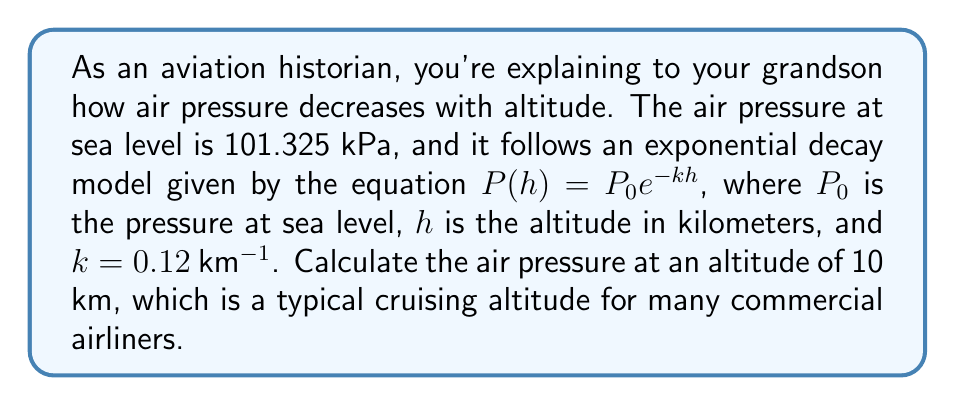Teach me how to tackle this problem. Let's approach this step-by-step:

1) We're given the exponential decay model:
   $P(h) = P_0 e^{-kh}$

2) We know the following values:
   $P_0 = 101.325$ kPa (pressure at sea level)
   $k = 0.12$ km^(-1)
   $h = 10$ km

3) Let's substitute these values into our equation:
   $P(10) = 101.325 \cdot e^{-0.12 \cdot 10}$

4) Simplify the exponent:
   $P(10) = 101.325 \cdot e^{-1.2}$

5) Calculate $e^{-1.2}$ (you can use a calculator for this):
   $e^{-1.2} \approx 0.301194$

6) Multiply:
   $P(10) = 101.325 \cdot 0.301194 \approx 30.5179$ kPa

7) Round to two decimal places:
   $P(10) \approx 30.52$ kPa

Therefore, at an altitude of 10 km, the air pressure is approximately 30.52 kPa.
Answer: 30.52 kPa 